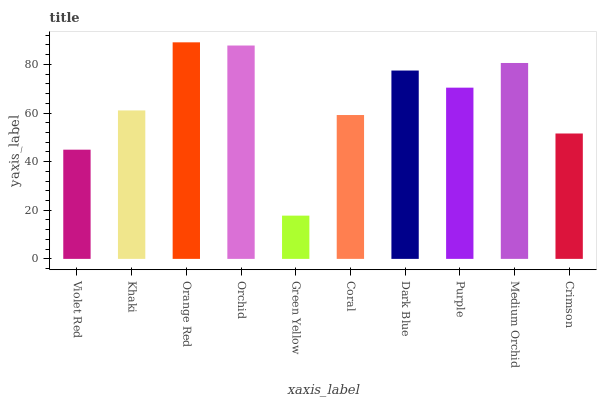Is Green Yellow the minimum?
Answer yes or no. Yes. Is Orange Red the maximum?
Answer yes or no. Yes. Is Khaki the minimum?
Answer yes or no. No. Is Khaki the maximum?
Answer yes or no. No. Is Khaki greater than Violet Red?
Answer yes or no. Yes. Is Violet Red less than Khaki?
Answer yes or no. Yes. Is Violet Red greater than Khaki?
Answer yes or no. No. Is Khaki less than Violet Red?
Answer yes or no. No. Is Purple the high median?
Answer yes or no. Yes. Is Khaki the low median?
Answer yes or no. Yes. Is Crimson the high median?
Answer yes or no. No. Is Orange Red the low median?
Answer yes or no. No. 